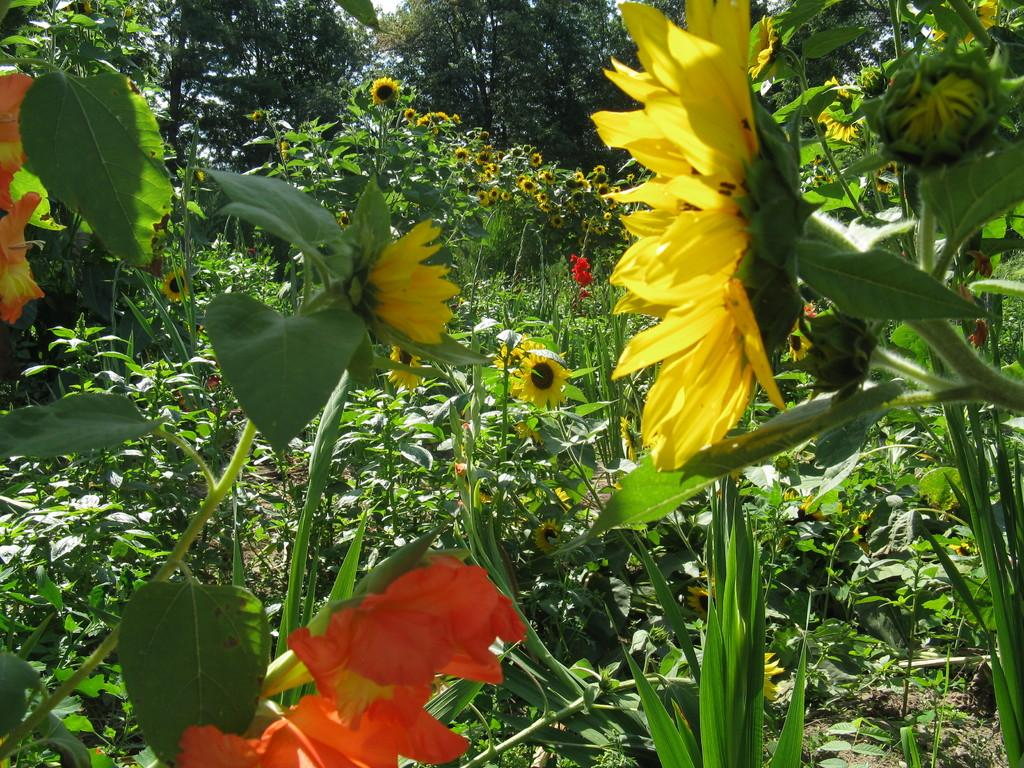What is the main subject in the center of the image? There are plants in the center of the image. What type of plants can be seen in the image? There are flowers in the image. What can be seen in the background of the image? There are trees in the background of the image. How many crates are stacked next to the flowers in the image? There are no crates present in the image. What type of dinosaurs can be seen roaming among the trees in the background? There are no dinosaurs present in the image; it features trees in the background. 